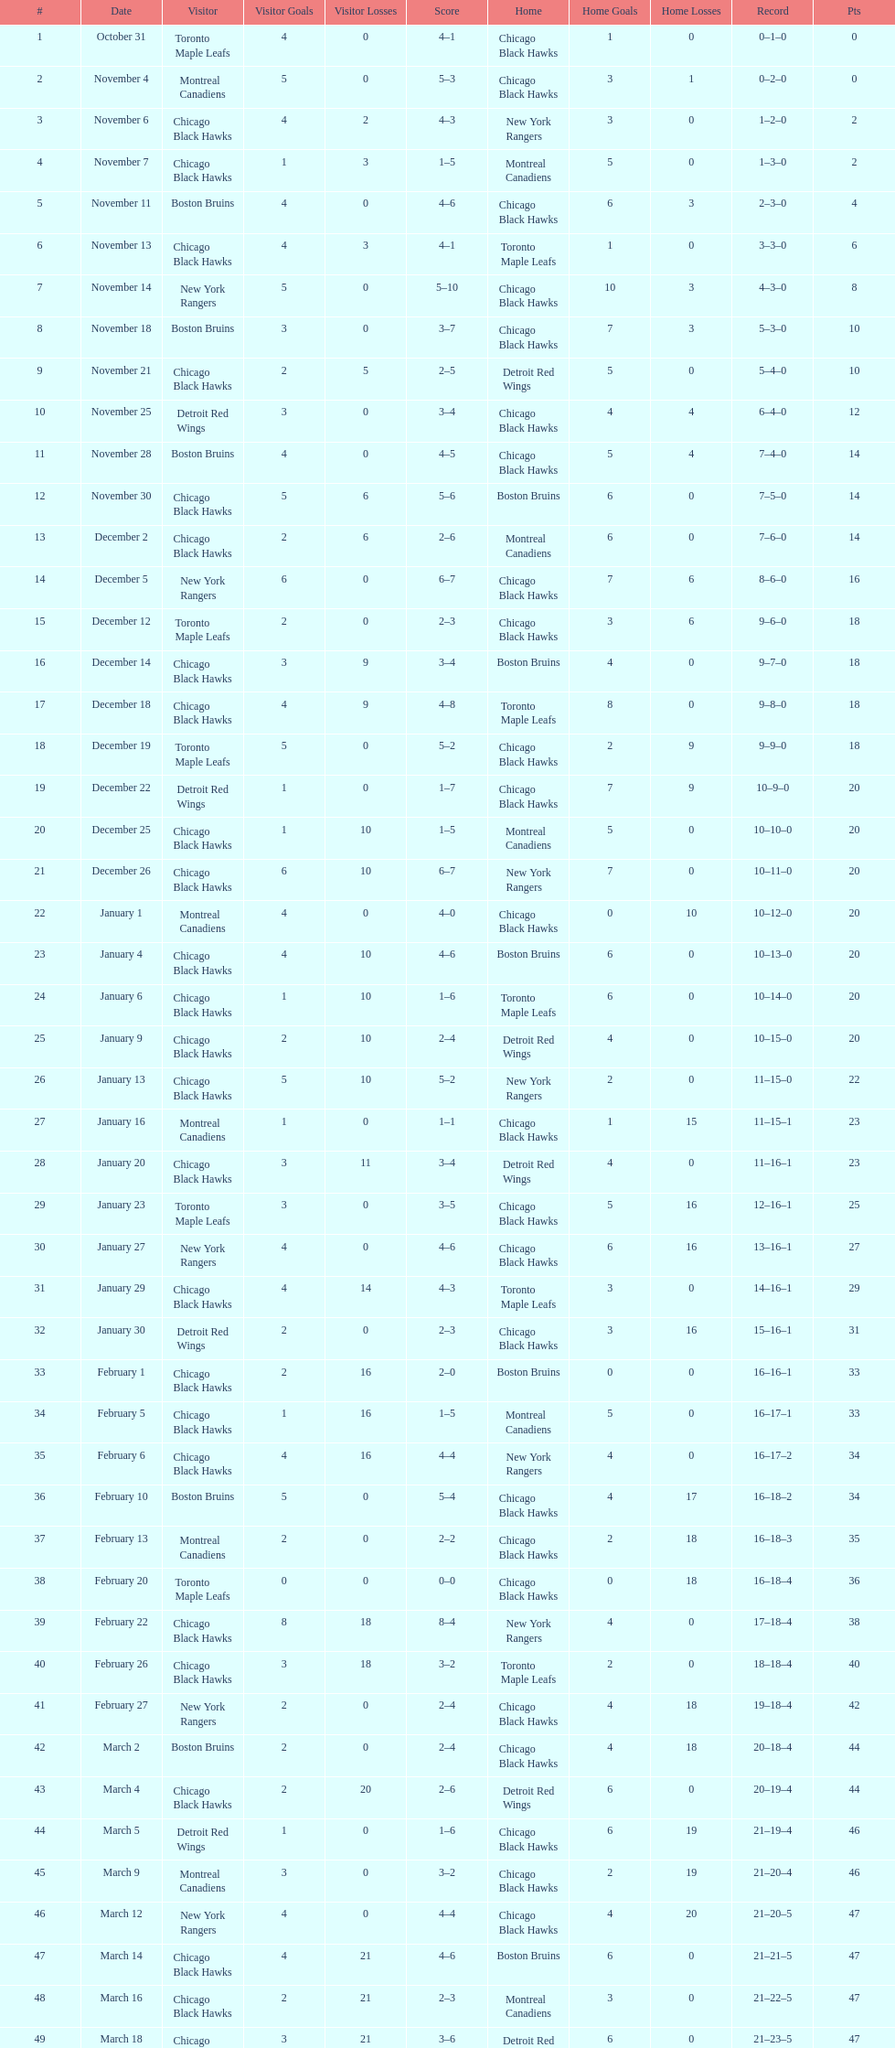What is the difference in pts between december 5th and november 11th? 3. 